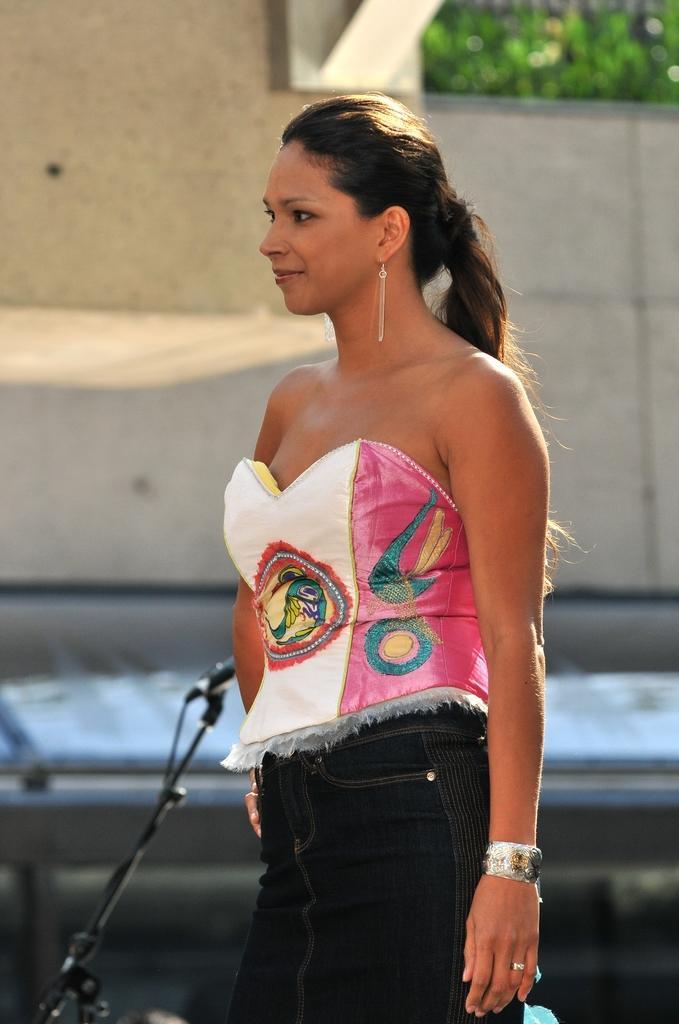Who is the main subject in the image? There is a lady in the image. What object is present that is typically used for amplifying sound? There is a mic in the image. What type of structure is visible in the image? There is a stand in the image. What is the background of the image made of? There is a wall in the image. What type of vegetation is present in the image? There are plants in the image. What type of pet can be seen interacting with the lady in the image? There is no pet present in the image. What force is being applied to the mic in the image? There is no force being applied to the mic in the image; it is stationary. Who is the writer of the text on the wall in the image? There is no text on the wall in the image, so it is not possible to determine who the writer might be. 